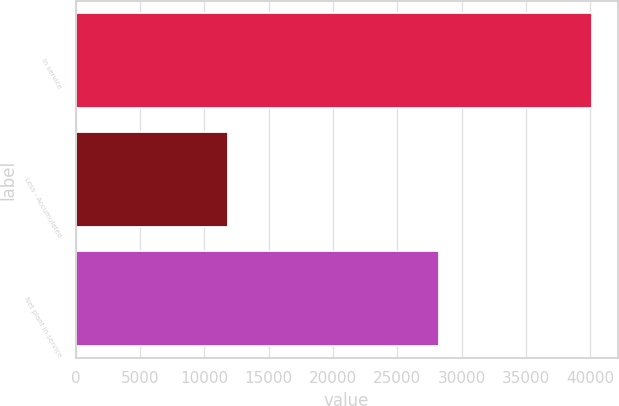<chart> <loc_0><loc_0><loc_500><loc_500><bar_chart><fcel>In service<fcel>Less - Accumulated<fcel>Net plant in service<nl><fcel>40122<fcel>11839<fcel>28283<nl></chart> 